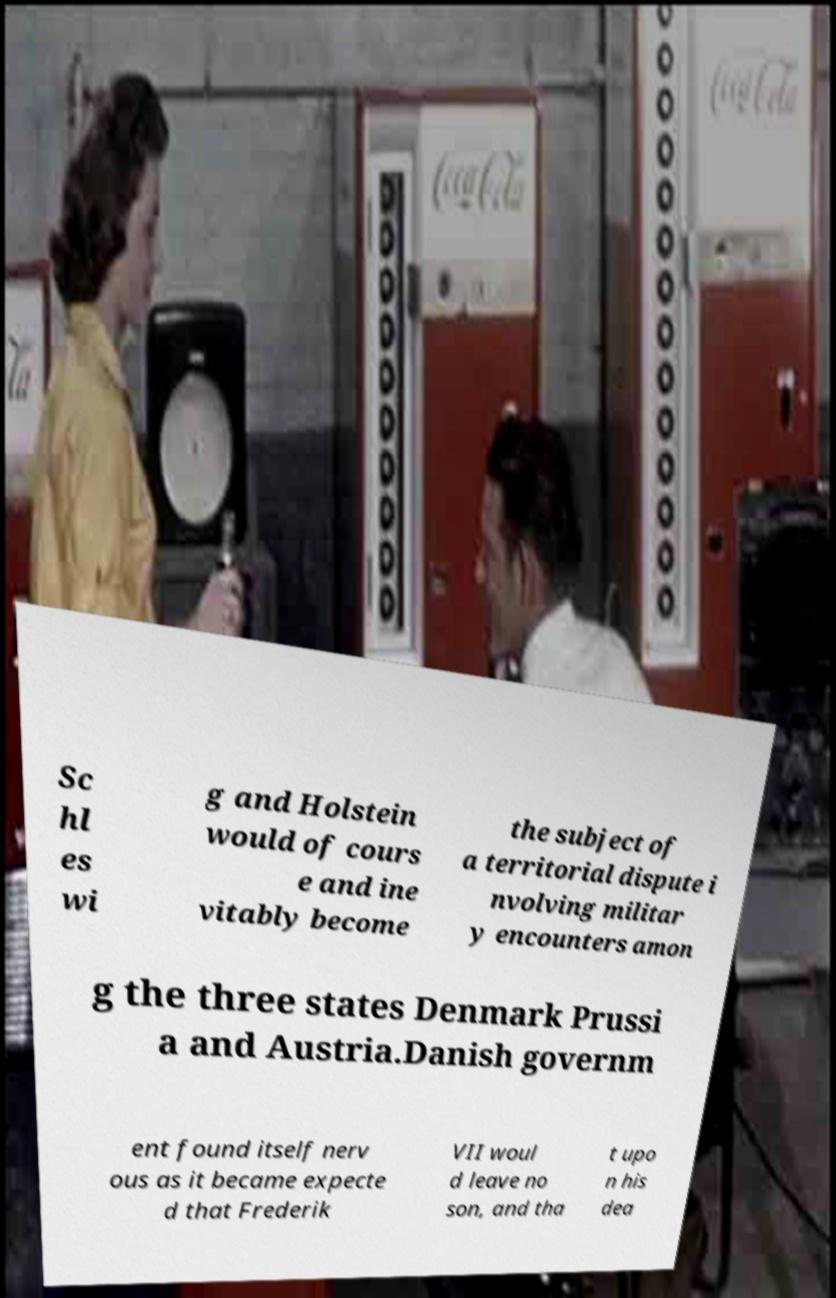For documentation purposes, I need the text within this image transcribed. Could you provide that? Sc hl es wi g and Holstein would of cours e and ine vitably become the subject of a territorial dispute i nvolving militar y encounters amon g the three states Denmark Prussi a and Austria.Danish governm ent found itself nerv ous as it became expecte d that Frederik VII woul d leave no son, and tha t upo n his dea 